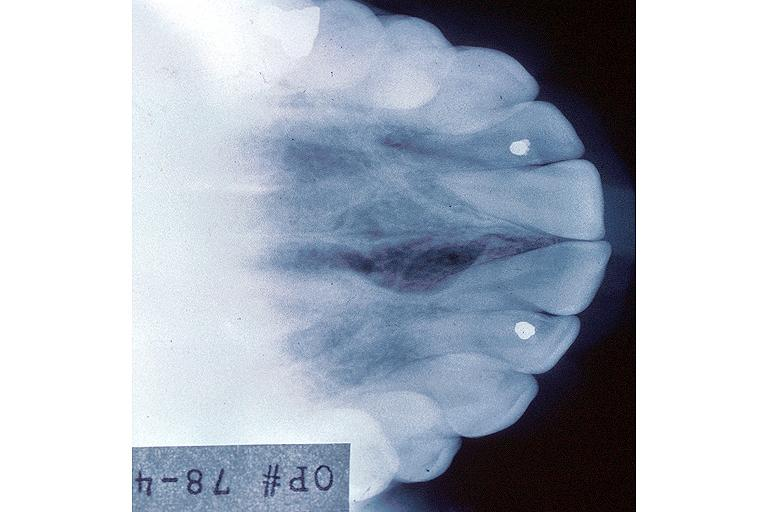does alpha smooth muscle actin immunohistochemical show incisive canal cyst nasopalatien duct cyst?
Answer the question using a single word or phrase. No 